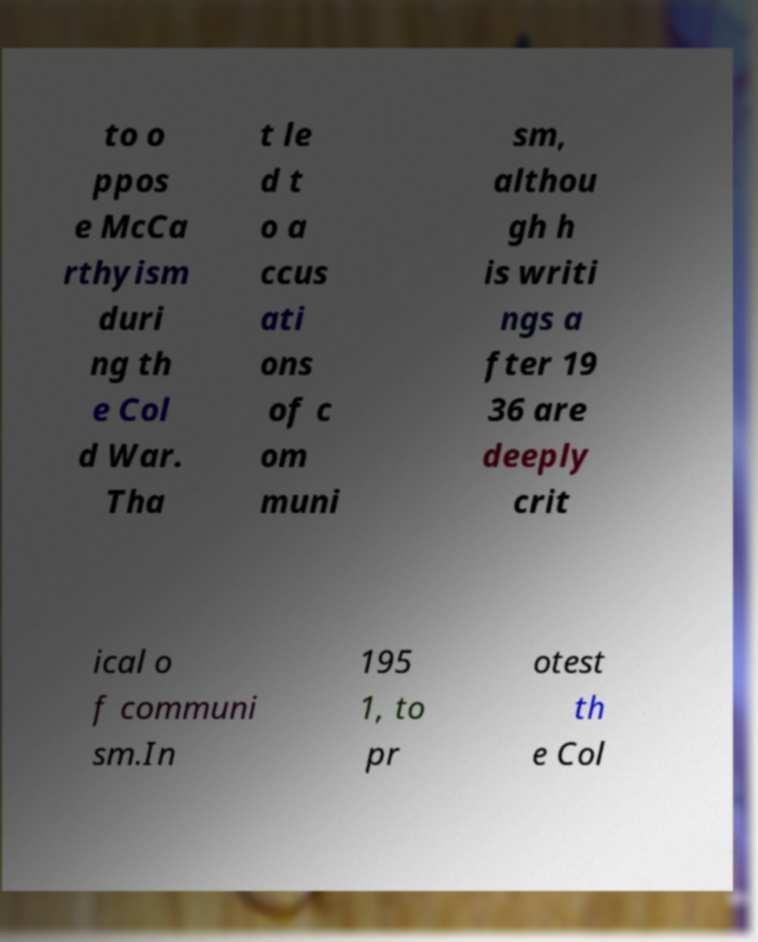Please identify and transcribe the text found in this image. to o ppos e McCa rthyism duri ng th e Col d War. Tha t le d t o a ccus ati ons of c om muni sm, althou gh h is writi ngs a fter 19 36 are deeply crit ical o f communi sm.In 195 1, to pr otest th e Col 